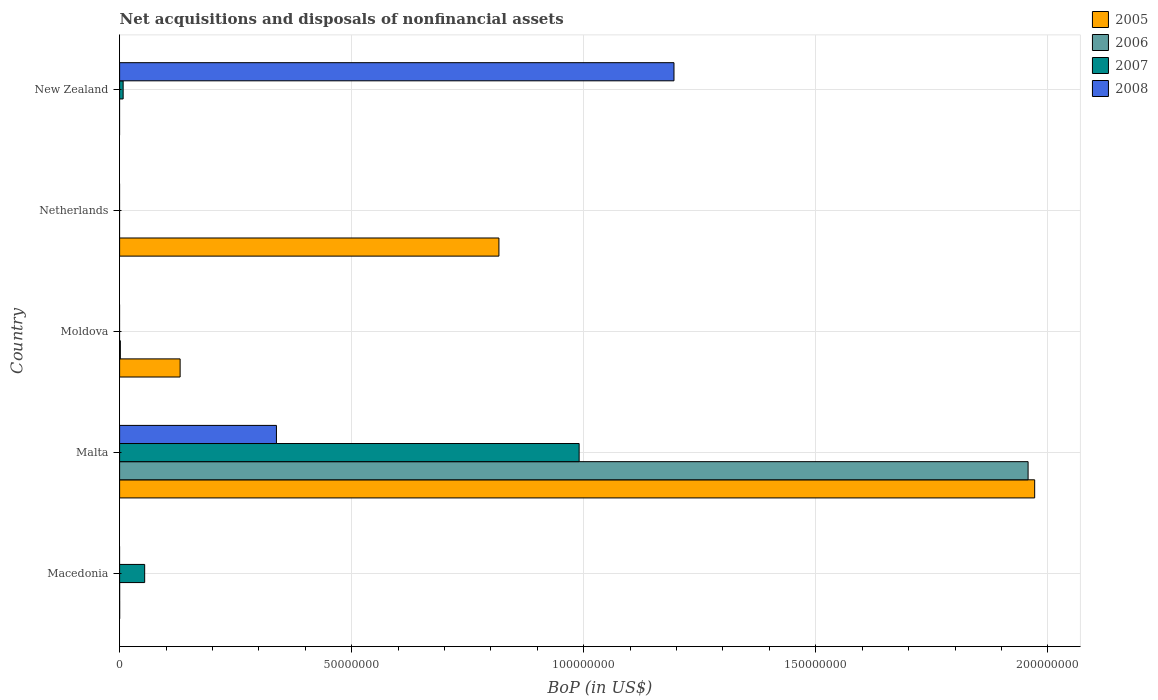How many different coloured bars are there?
Keep it short and to the point. 4. What is the label of the 1st group of bars from the top?
Ensure brevity in your answer.  New Zealand. What is the Balance of Payments in 2006 in Netherlands?
Give a very brief answer. 0. Across all countries, what is the maximum Balance of Payments in 2008?
Offer a terse response. 1.19e+08. Across all countries, what is the minimum Balance of Payments in 2006?
Ensure brevity in your answer.  0. In which country was the Balance of Payments in 2006 maximum?
Your answer should be very brief. Malta. What is the total Balance of Payments in 2006 in the graph?
Provide a short and direct response. 1.96e+08. What is the difference between the Balance of Payments in 2005 in Malta and that in Netherlands?
Your answer should be compact. 1.15e+08. What is the difference between the Balance of Payments in 2007 in Moldova and the Balance of Payments in 2008 in Malta?
Give a very brief answer. -3.38e+07. What is the average Balance of Payments in 2008 per country?
Ensure brevity in your answer.  3.06e+07. What is the difference between the Balance of Payments in 2006 and Balance of Payments in 2005 in Moldova?
Provide a short and direct response. -1.29e+07. In how many countries, is the Balance of Payments in 2006 greater than 140000000 US$?
Give a very brief answer. 1. What is the ratio of the Balance of Payments in 2008 in Malta to that in New Zealand?
Your response must be concise. 0.28. Is the Balance of Payments in 2006 in Macedonia less than that in Malta?
Offer a very short reply. Yes. What is the difference between the highest and the second highest Balance of Payments in 2007?
Provide a short and direct response. 9.36e+07. What is the difference between the highest and the lowest Balance of Payments in 2006?
Make the answer very short. 1.96e+08. In how many countries, is the Balance of Payments in 2006 greater than the average Balance of Payments in 2006 taken over all countries?
Offer a very short reply. 1. Is it the case that in every country, the sum of the Balance of Payments in 2007 and Balance of Payments in 2006 is greater than the sum of Balance of Payments in 2005 and Balance of Payments in 2008?
Make the answer very short. No. How many bars are there?
Provide a succinct answer. 12. Are all the bars in the graph horizontal?
Keep it short and to the point. Yes. Are the values on the major ticks of X-axis written in scientific E-notation?
Your answer should be compact. No. Does the graph contain grids?
Your answer should be compact. Yes. How are the legend labels stacked?
Provide a short and direct response. Vertical. What is the title of the graph?
Your answer should be very brief. Net acquisitions and disposals of nonfinancial assets. Does "1980" appear as one of the legend labels in the graph?
Offer a very short reply. No. What is the label or title of the X-axis?
Give a very brief answer. BoP (in US$). What is the BoP (in US$) in 2005 in Macedonia?
Ensure brevity in your answer.  7057.87. What is the BoP (in US$) in 2006 in Macedonia?
Provide a short and direct response. 4585.23. What is the BoP (in US$) in 2007 in Macedonia?
Your answer should be very brief. 5.40e+06. What is the BoP (in US$) in 2008 in Macedonia?
Ensure brevity in your answer.  0. What is the BoP (in US$) in 2005 in Malta?
Provide a succinct answer. 1.97e+08. What is the BoP (in US$) in 2006 in Malta?
Ensure brevity in your answer.  1.96e+08. What is the BoP (in US$) of 2007 in Malta?
Your answer should be compact. 9.90e+07. What is the BoP (in US$) of 2008 in Malta?
Provide a short and direct response. 3.38e+07. What is the BoP (in US$) of 2005 in Moldova?
Ensure brevity in your answer.  1.30e+07. What is the BoP (in US$) of 2007 in Moldova?
Your answer should be compact. 0. What is the BoP (in US$) in 2005 in Netherlands?
Offer a very short reply. 8.17e+07. What is the BoP (in US$) in 2007 in Netherlands?
Your answer should be very brief. 0. What is the BoP (in US$) of 2005 in New Zealand?
Ensure brevity in your answer.  0. What is the BoP (in US$) of 2007 in New Zealand?
Your response must be concise. 7.64e+05. What is the BoP (in US$) in 2008 in New Zealand?
Offer a terse response. 1.19e+08. Across all countries, what is the maximum BoP (in US$) of 2005?
Give a very brief answer. 1.97e+08. Across all countries, what is the maximum BoP (in US$) of 2006?
Ensure brevity in your answer.  1.96e+08. Across all countries, what is the maximum BoP (in US$) of 2007?
Make the answer very short. 9.90e+07. Across all countries, what is the maximum BoP (in US$) in 2008?
Provide a succinct answer. 1.19e+08. Across all countries, what is the minimum BoP (in US$) of 2005?
Offer a very short reply. 0. Across all countries, what is the minimum BoP (in US$) of 2007?
Provide a short and direct response. 0. What is the total BoP (in US$) of 2005 in the graph?
Make the answer very short. 2.92e+08. What is the total BoP (in US$) in 2006 in the graph?
Make the answer very short. 1.96e+08. What is the total BoP (in US$) in 2007 in the graph?
Provide a succinct answer. 1.05e+08. What is the total BoP (in US$) in 2008 in the graph?
Offer a very short reply. 1.53e+08. What is the difference between the BoP (in US$) in 2005 in Macedonia and that in Malta?
Your response must be concise. -1.97e+08. What is the difference between the BoP (in US$) in 2006 in Macedonia and that in Malta?
Your response must be concise. -1.96e+08. What is the difference between the BoP (in US$) in 2007 in Macedonia and that in Malta?
Provide a short and direct response. -9.36e+07. What is the difference between the BoP (in US$) in 2005 in Macedonia and that in Moldova?
Make the answer very short. -1.30e+07. What is the difference between the BoP (in US$) in 2006 in Macedonia and that in Moldova?
Your answer should be compact. -1.55e+05. What is the difference between the BoP (in US$) of 2005 in Macedonia and that in Netherlands?
Provide a short and direct response. -8.17e+07. What is the difference between the BoP (in US$) of 2007 in Macedonia and that in New Zealand?
Provide a succinct answer. 4.64e+06. What is the difference between the BoP (in US$) in 2005 in Malta and that in Moldova?
Give a very brief answer. 1.84e+08. What is the difference between the BoP (in US$) of 2006 in Malta and that in Moldova?
Offer a very short reply. 1.96e+08. What is the difference between the BoP (in US$) in 2005 in Malta and that in Netherlands?
Provide a succinct answer. 1.15e+08. What is the difference between the BoP (in US$) of 2007 in Malta and that in New Zealand?
Offer a very short reply. 9.82e+07. What is the difference between the BoP (in US$) in 2008 in Malta and that in New Zealand?
Ensure brevity in your answer.  -8.57e+07. What is the difference between the BoP (in US$) in 2005 in Moldova and that in Netherlands?
Your answer should be very brief. -6.87e+07. What is the difference between the BoP (in US$) in 2005 in Macedonia and the BoP (in US$) in 2006 in Malta?
Provide a short and direct response. -1.96e+08. What is the difference between the BoP (in US$) in 2005 in Macedonia and the BoP (in US$) in 2007 in Malta?
Provide a short and direct response. -9.90e+07. What is the difference between the BoP (in US$) in 2005 in Macedonia and the BoP (in US$) in 2008 in Malta?
Offer a terse response. -3.38e+07. What is the difference between the BoP (in US$) of 2006 in Macedonia and the BoP (in US$) of 2007 in Malta?
Your response must be concise. -9.90e+07. What is the difference between the BoP (in US$) in 2006 in Macedonia and the BoP (in US$) in 2008 in Malta?
Your answer should be compact. -3.38e+07. What is the difference between the BoP (in US$) of 2007 in Macedonia and the BoP (in US$) of 2008 in Malta?
Your answer should be compact. -2.84e+07. What is the difference between the BoP (in US$) of 2005 in Macedonia and the BoP (in US$) of 2006 in Moldova?
Keep it short and to the point. -1.53e+05. What is the difference between the BoP (in US$) in 2005 in Macedonia and the BoP (in US$) in 2007 in New Zealand?
Provide a succinct answer. -7.57e+05. What is the difference between the BoP (in US$) of 2005 in Macedonia and the BoP (in US$) of 2008 in New Zealand?
Keep it short and to the point. -1.19e+08. What is the difference between the BoP (in US$) of 2006 in Macedonia and the BoP (in US$) of 2007 in New Zealand?
Make the answer very short. -7.59e+05. What is the difference between the BoP (in US$) in 2006 in Macedonia and the BoP (in US$) in 2008 in New Zealand?
Ensure brevity in your answer.  -1.19e+08. What is the difference between the BoP (in US$) in 2007 in Macedonia and the BoP (in US$) in 2008 in New Zealand?
Provide a succinct answer. -1.14e+08. What is the difference between the BoP (in US$) in 2005 in Malta and the BoP (in US$) in 2006 in Moldova?
Offer a terse response. 1.97e+08. What is the difference between the BoP (in US$) of 2005 in Malta and the BoP (in US$) of 2007 in New Zealand?
Keep it short and to the point. 1.96e+08. What is the difference between the BoP (in US$) in 2005 in Malta and the BoP (in US$) in 2008 in New Zealand?
Your answer should be very brief. 7.77e+07. What is the difference between the BoP (in US$) in 2006 in Malta and the BoP (in US$) in 2007 in New Zealand?
Make the answer very short. 1.95e+08. What is the difference between the BoP (in US$) of 2006 in Malta and the BoP (in US$) of 2008 in New Zealand?
Your answer should be compact. 7.63e+07. What is the difference between the BoP (in US$) in 2007 in Malta and the BoP (in US$) in 2008 in New Zealand?
Your response must be concise. -2.04e+07. What is the difference between the BoP (in US$) of 2005 in Moldova and the BoP (in US$) of 2007 in New Zealand?
Give a very brief answer. 1.23e+07. What is the difference between the BoP (in US$) of 2005 in Moldova and the BoP (in US$) of 2008 in New Zealand?
Your response must be concise. -1.06e+08. What is the difference between the BoP (in US$) in 2006 in Moldova and the BoP (in US$) in 2007 in New Zealand?
Provide a succinct answer. -6.04e+05. What is the difference between the BoP (in US$) in 2006 in Moldova and the BoP (in US$) in 2008 in New Zealand?
Make the answer very short. -1.19e+08. What is the difference between the BoP (in US$) of 2005 in Netherlands and the BoP (in US$) of 2007 in New Zealand?
Ensure brevity in your answer.  8.10e+07. What is the difference between the BoP (in US$) of 2005 in Netherlands and the BoP (in US$) of 2008 in New Zealand?
Offer a terse response. -3.77e+07. What is the average BoP (in US$) in 2005 per country?
Your answer should be very brief. 5.84e+07. What is the average BoP (in US$) of 2006 per country?
Provide a succinct answer. 3.92e+07. What is the average BoP (in US$) in 2007 per country?
Offer a terse response. 2.10e+07. What is the average BoP (in US$) in 2008 per country?
Make the answer very short. 3.06e+07. What is the difference between the BoP (in US$) in 2005 and BoP (in US$) in 2006 in Macedonia?
Provide a succinct answer. 2472.64. What is the difference between the BoP (in US$) in 2005 and BoP (in US$) in 2007 in Macedonia?
Offer a very short reply. -5.39e+06. What is the difference between the BoP (in US$) of 2006 and BoP (in US$) of 2007 in Macedonia?
Keep it short and to the point. -5.40e+06. What is the difference between the BoP (in US$) of 2005 and BoP (in US$) of 2006 in Malta?
Offer a terse response. 1.42e+06. What is the difference between the BoP (in US$) in 2005 and BoP (in US$) in 2007 in Malta?
Your response must be concise. 9.81e+07. What is the difference between the BoP (in US$) in 2005 and BoP (in US$) in 2008 in Malta?
Provide a short and direct response. 1.63e+08. What is the difference between the BoP (in US$) in 2006 and BoP (in US$) in 2007 in Malta?
Keep it short and to the point. 9.67e+07. What is the difference between the BoP (in US$) in 2006 and BoP (in US$) in 2008 in Malta?
Your answer should be very brief. 1.62e+08. What is the difference between the BoP (in US$) in 2007 and BoP (in US$) in 2008 in Malta?
Make the answer very short. 6.52e+07. What is the difference between the BoP (in US$) of 2005 and BoP (in US$) of 2006 in Moldova?
Your answer should be very brief. 1.29e+07. What is the difference between the BoP (in US$) in 2007 and BoP (in US$) in 2008 in New Zealand?
Keep it short and to the point. -1.19e+08. What is the ratio of the BoP (in US$) of 2007 in Macedonia to that in Malta?
Offer a terse response. 0.05. What is the ratio of the BoP (in US$) in 2006 in Macedonia to that in Moldova?
Your answer should be very brief. 0.03. What is the ratio of the BoP (in US$) in 2005 in Macedonia to that in Netherlands?
Offer a terse response. 0. What is the ratio of the BoP (in US$) in 2007 in Macedonia to that in New Zealand?
Give a very brief answer. 7.07. What is the ratio of the BoP (in US$) in 2005 in Malta to that in Moldova?
Ensure brevity in your answer.  15.12. What is the ratio of the BoP (in US$) in 2006 in Malta to that in Moldova?
Offer a very short reply. 1223.36. What is the ratio of the BoP (in US$) in 2005 in Malta to that in Netherlands?
Offer a terse response. 2.41. What is the ratio of the BoP (in US$) in 2007 in Malta to that in New Zealand?
Your response must be concise. 129.62. What is the ratio of the BoP (in US$) of 2008 in Malta to that in New Zealand?
Keep it short and to the point. 0.28. What is the ratio of the BoP (in US$) in 2005 in Moldova to that in Netherlands?
Your response must be concise. 0.16. What is the difference between the highest and the second highest BoP (in US$) of 2005?
Your response must be concise. 1.15e+08. What is the difference between the highest and the second highest BoP (in US$) of 2006?
Give a very brief answer. 1.96e+08. What is the difference between the highest and the second highest BoP (in US$) in 2007?
Offer a terse response. 9.36e+07. What is the difference between the highest and the lowest BoP (in US$) in 2005?
Keep it short and to the point. 1.97e+08. What is the difference between the highest and the lowest BoP (in US$) of 2006?
Make the answer very short. 1.96e+08. What is the difference between the highest and the lowest BoP (in US$) of 2007?
Make the answer very short. 9.90e+07. What is the difference between the highest and the lowest BoP (in US$) in 2008?
Provide a short and direct response. 1.19e+08. 